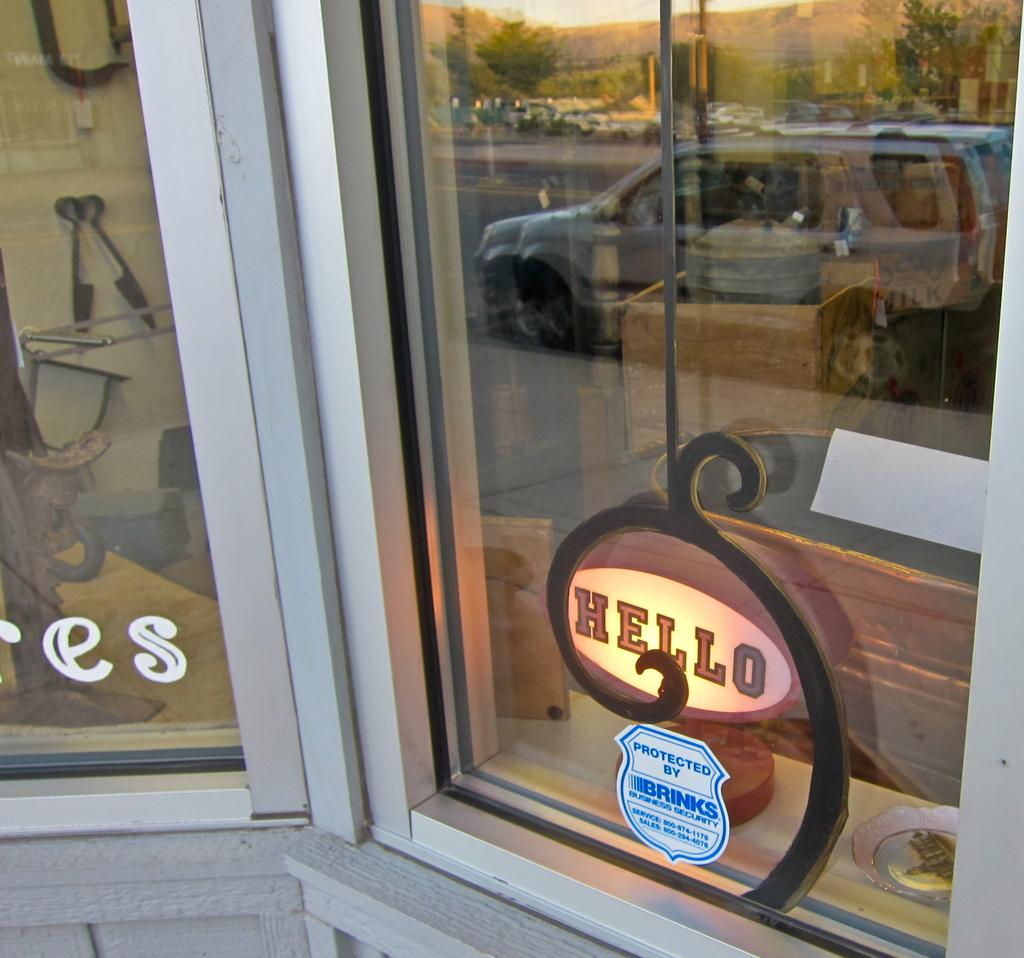What is present in the image that allows for a view of the outside? There is a glass window in the image. What can be seen in the reflection of the glass window? The glass window has a reflection of a car. What type of beast can be seen on the calendar in the image? There is no calendar present in the image, and therefore no beast can be seen on it. 